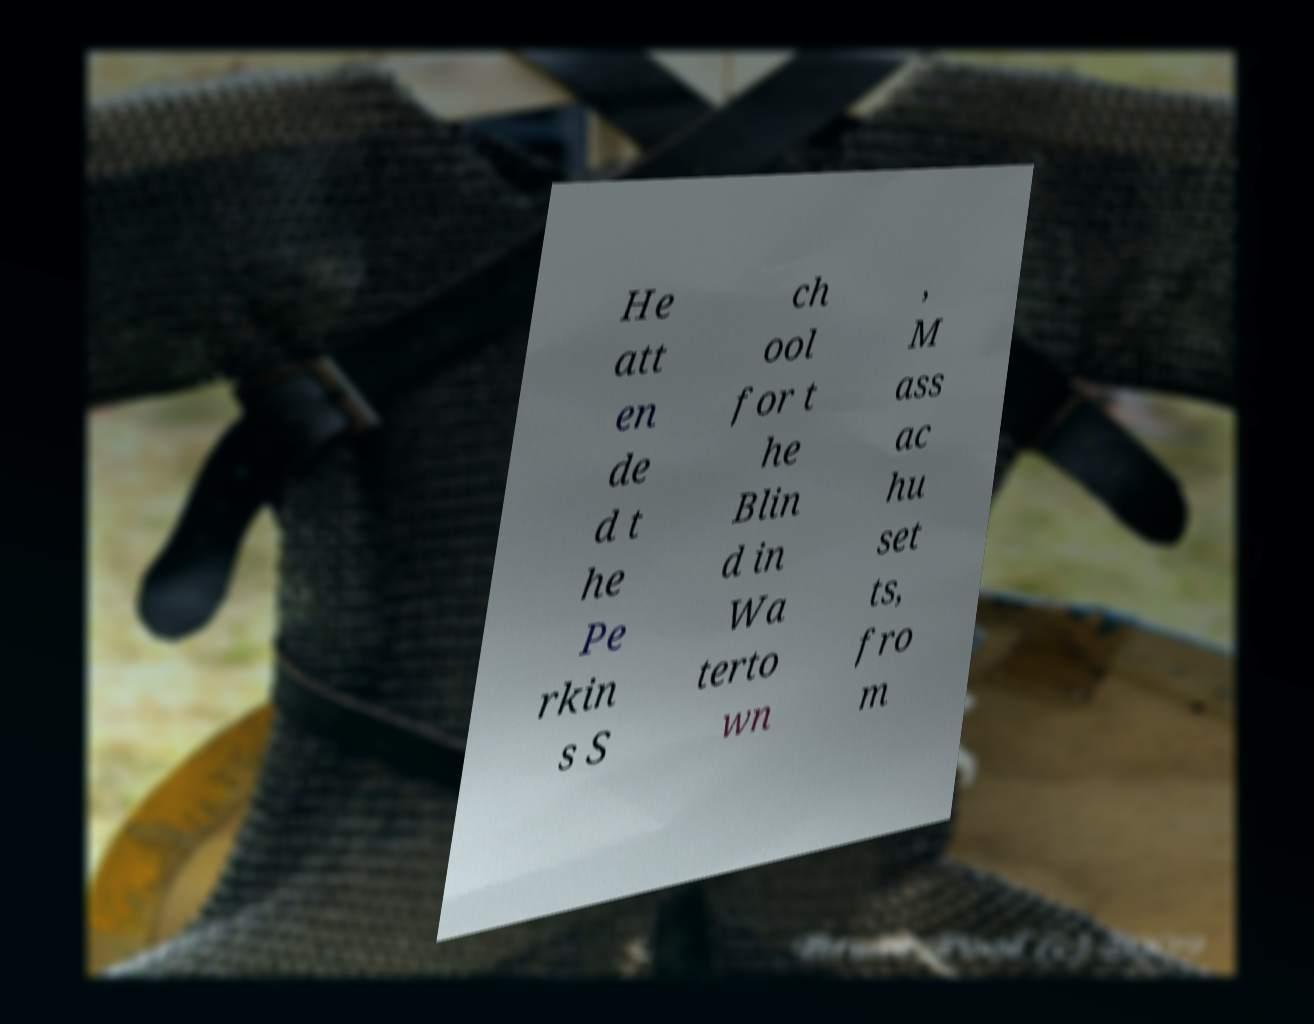Could you extract and type out the text from this image? He att en de d t he Pe rkin s S ch ool for t he Blin d in Wa terto wn , M ass ac hu set ts, fro m 